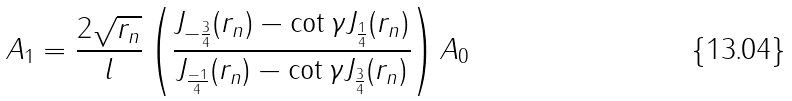Convert formula to latex. <formula><loc_0><loc_0><loc_500><loc_500>A _ { 1 } = \frac { 2 \sqrt { r _ { n } } } { l } \left ( \frac { J _ { - \frac { 3 } { 4 } } ( r _ { n } ) - \cot \gamma J _ { \frac { 1 } { 4 } } ( r _ { n } ) } { J _ { \frac { - 1 } { 4 } } ( r _ { n } ) - \cot \gamma J _ { \frac { 3 } { 4 } } ( r _ { n } ) } \right ) A _ { 0 }</formula> 